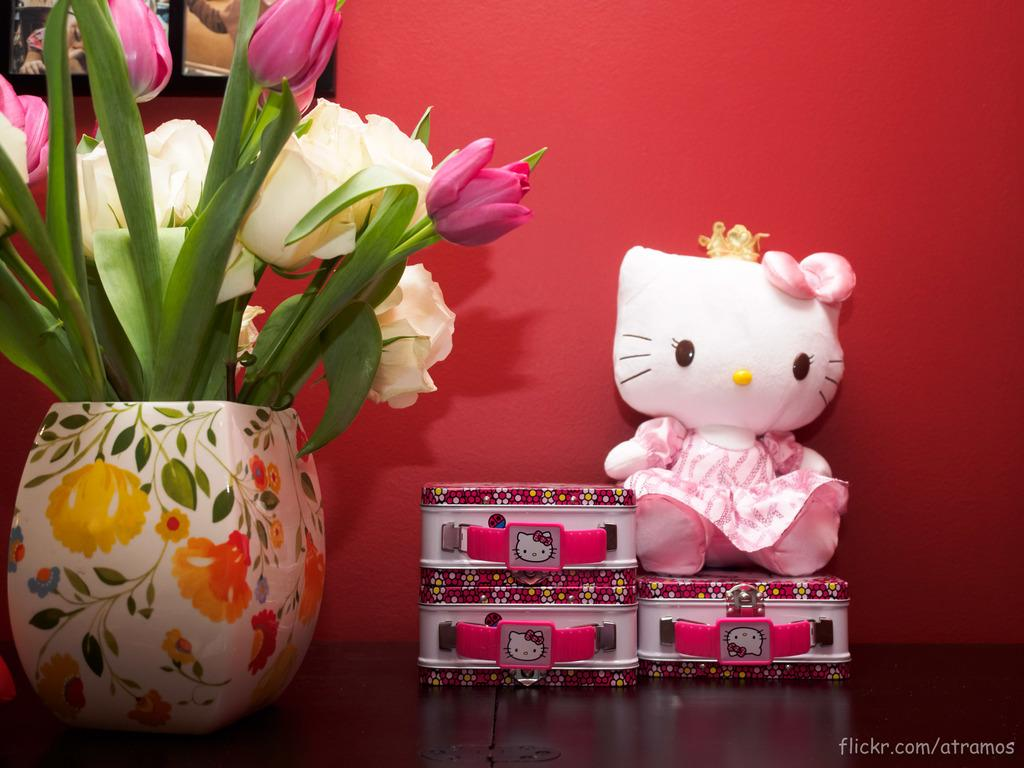What is the main subject in the center of the image? There is a houseplant in the center of the image. What other object can be seen in the image? There is a toy placed on the table in the image. What is visible in the background of the image? There is a wall in the background of the image. How much blood can be seen on the toy in the image? There is no blood visible on the toy in the image. What type of lipstick is being used by the houseplant in the image? There is no lipstick or any indication of cosmetics in the image; it features a houseplant and a toy on a table. 